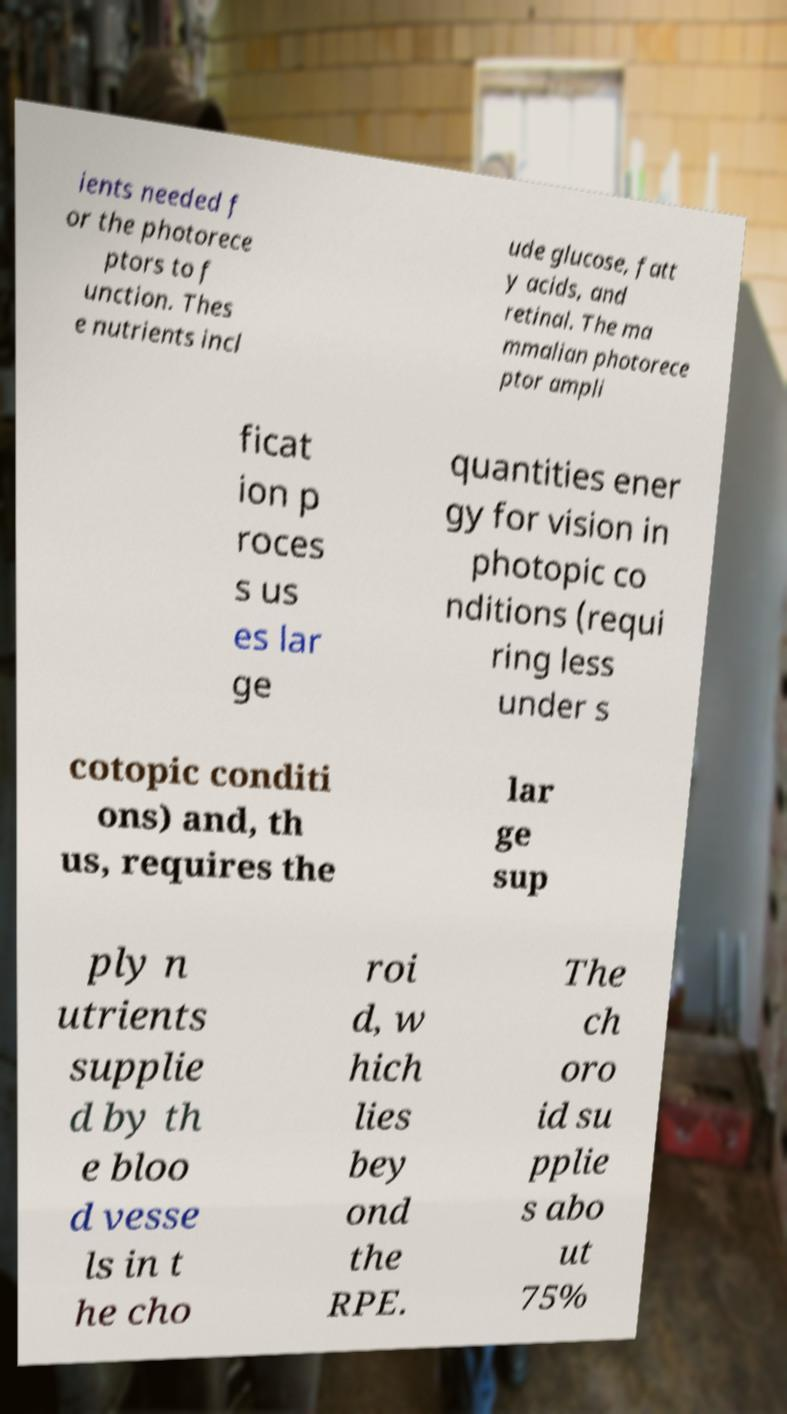Can you read and provide the text displayed in the image?This photo seems to have some interesting text. Can you extract and type it out for me? ients needed f or the photorece ptors to f unction. Thes e nutrients incl ude glucose, fatt y acids, and retinal. The ma mmalian photorece ptor ampli ficat ion p roces s us es lar ge quantities ener gy for vision in photopic co nditions (requi ring less under s cotopic conditi ons) and, th us, requires the lar ge sup ply n utrients supplie d by th e bloo d vesse ls in t he cho roi d, w hich lies bey ond the RPE. The ch oro id su pplie s abo ut 75% 